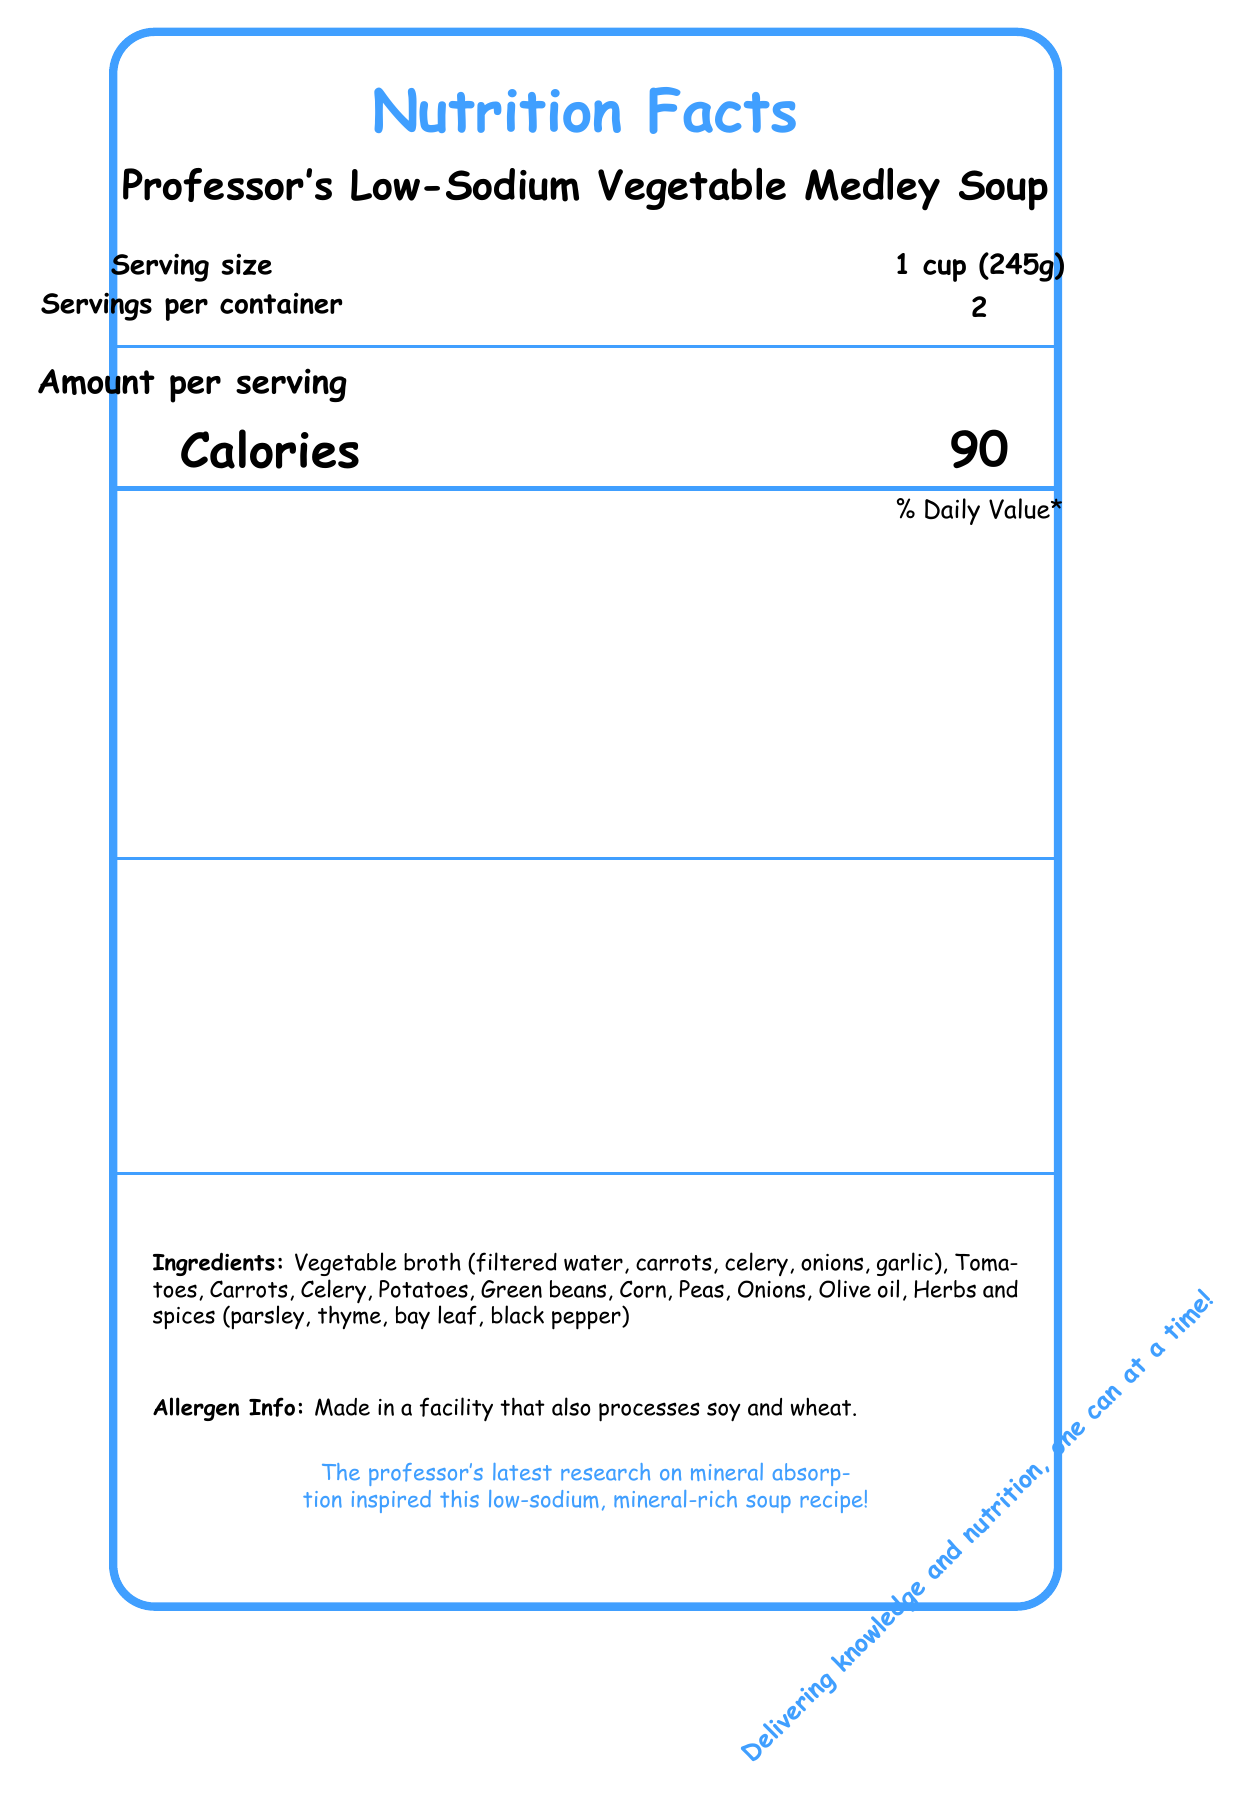what is the serving size? The serving size is clearly listed near the top of the document.
Answer: 1 cup (245g) how many calories are there per serving? The calories per serving is shown in large, bold text in the "Amount per serving" section.
Answer: 90 how much sodium does one serving contain? The sodium content is listed under the "Total Fat" section in the table format.
Answer: 140 mg what percentage of daily value of dietary fiber does one serving provide? The percentage daily value of dietary fiber is stated as 11% under the "Total Carbohydrate" section.
Answer: 11% how much protein is in one serving? The protein content per serving is listed in the table as 4g.
Answer: 4g what is the serving size for Professor's Low-Sodium Vegetable Medley Soup? A. 2 cups B. 1 cup (245g) C. Half a cup D. 3 cups The serving size is specified as 1 cup (245g) near the top section of the document.
Answer: B what mineral content provides 10% of the daily value? A. Calcium B. Iron C. Potassium D. Magnesium Potassium provides 10% of the daily value as indicated in the table in the vitamins and minerals section.
Answer: C does the soup contain any cholesterol? The document states that the soup contains 0mg of cholesterol, which equals 0% of the daily value.
Answer: No what are the ingredients of the soup? The ingredients are detailed at the bottom of the document under the "Ingredients" section.
Answer: Vegetable broth (filtered water, carrots, celery, onions, garlic), Tomatoes, Carrots, Celery, Potatoes, Green beans, Corn, Peas, Onions, Olive oil, Herbs and spices (parsley, thyme, bay leaf, black pepper) does the soup contain added sugars? The "Includes 0g Added Sugars" is printed in the "Total Carbohydrate" section, indicating no added sugars.
Answer: No summarize the main details of the nutrition facts document. The document outlines the nutritional breakdown of the soup, including its low sodium content and rich mineral profile while listing all the ingredients and allergen information.
Answer: This document provides the nutritional information for Professor's Low-Sodium Vegetable Medley Soup, including serving size, servings per container, calories, amounts and daily values of macronutrients (fat, cholesterol, sodium, carbohydrate, sugars, protein) and micronutrients (vitamins and minerals). The document also includes the list of ingredients, allergen information, and a fun fact about the professor’s research inspiration. how much phosphorus is in one serving of the soup? The amount of phosphorus per serving is listed in the vitamins and minerals table.
Answer: 60 mg who is the professor referred to in the document? The document does not provide the specific identity or name of the professor.
Answer: Not enough information 